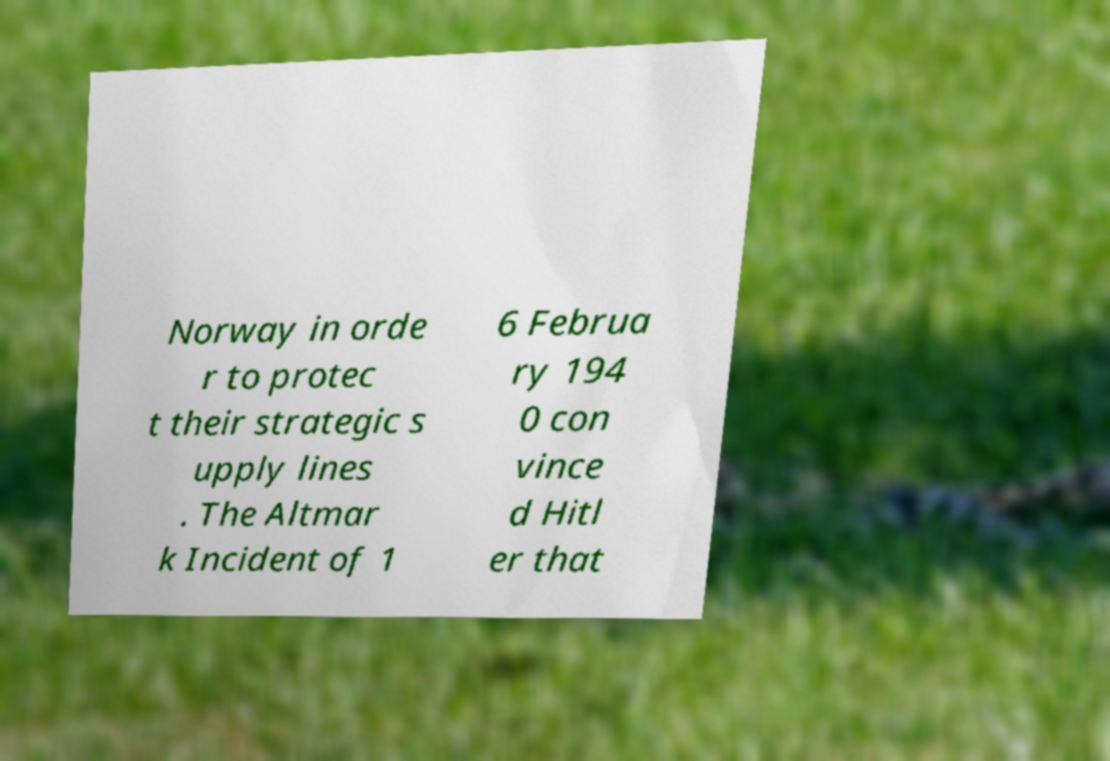Could you extract and type out the text from this image? Norway in orde r to protec t their strategic s upply lines . The Altmar k Incident of 1 6 Februa ry 194 0 con vince d Hitl er that 